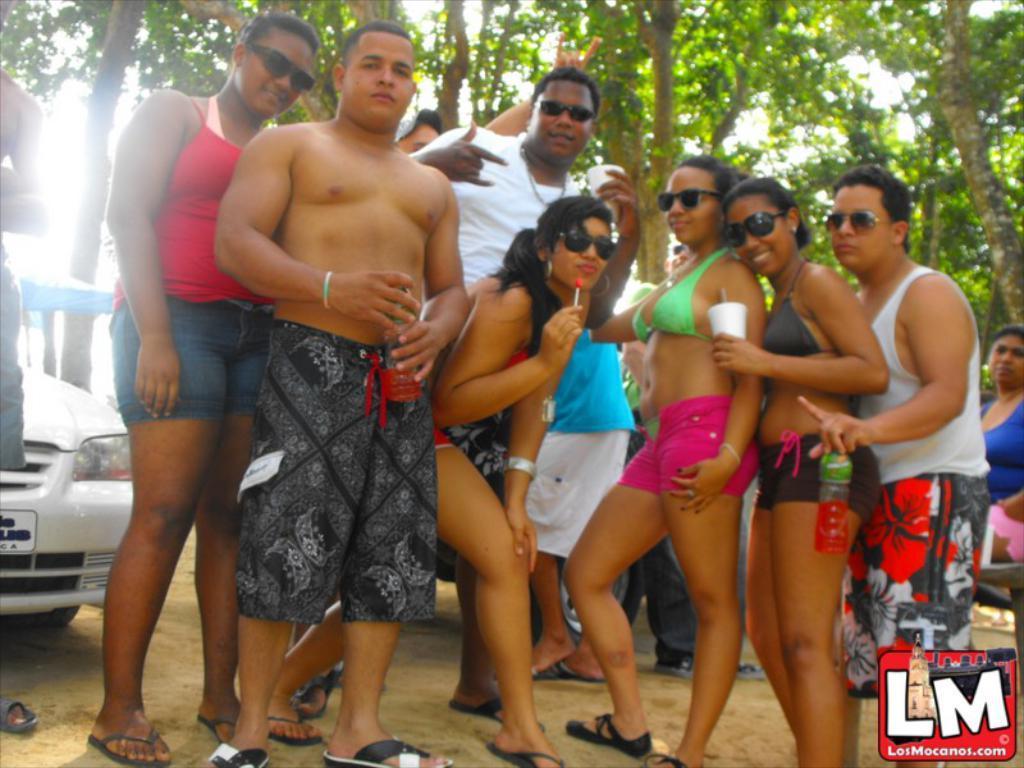Can you describe this image briefly? In this image, we can see people posing for photo and in the background, we can see a vehicle and there are trees. 